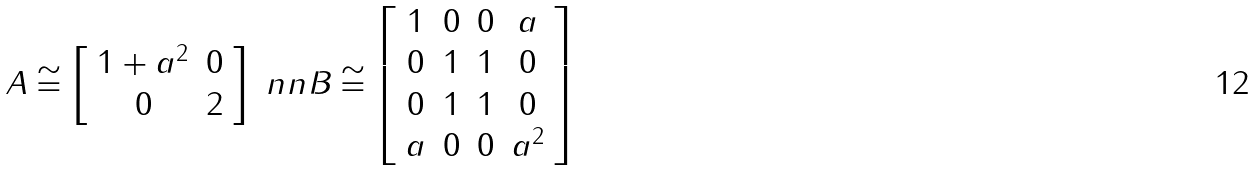Convert formula to latex. <formula><loc_0><loc_0><loc_500><loc_500>A \cong \left [ \begin{array} { c c } 1 + a ^ { 2 } & 0 \\ 0 & 2 \end{array} \right ] \ n n B \cong \left [ \begin{array} { c c c c } 1 & 0 & 0 & a \\ 0 & 1 & 1 & 0 \\ 0 & 1 & 1 & 0 \\ a & 0 & 0 & a ^ { 2 } \end{array} \right ]</formula> 